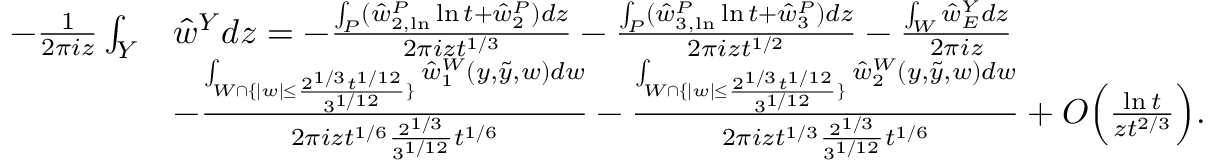Convert formula to latex. <formula><loc_0><loc_0><loc_500><loc_500>\begin{array} { r l } { - \frac { 1 } { 2 \pi i z } \int _ { Y } } & { \hat { w } ^ { Y } d z = - \frac { \int _ { P } ( \hat { w } _ { 2 , \ln } ^ { P } \ln { t } + \hat { w } _ { 2 } ^ { P } ) d z } { 2 \pi i z t ^ { 1 / 3 } } - \frac { \int _ { P } ( \hat { w } _ { 3 , \ln } ^ { P } \ln { t } + \hat { w } _ { 3 } ^ { P } ) d z } { 2 \pi i z t ^ { 1 / 2 } } - \frac { \int _ { W } \hat { w } _ { E } ^ { Y } d z } { 2 \pi i z } } \\ & { - \frac { \int _ { W \cap \{ | w | \leq \frac { 2 ^ { 1 / 3 } t ^ { 1 / 1 2 } } { 3 ^ { 1 / 1 2 } } \} } \hat { w } _ { 1 } ^ { W } ( y , \tilde { y } , w ) d w } { 2 \pi i z t ^ { 1 / 6 } \frac { 2 ^ { 1 / 3 } } { 3 ^ { 1 / 1 2 } } t ^ { 1 / 6 } } - \frac { \int _ { W \cap \{ | w | \leq \frac { 2 ^ { 1 / 3 } t ^ { 1 / 1 2 } } { 3 ^ { 1 / 1 2 } } \} } \hat { w } _ { 2 } ^ { W } ( y , \tilde { y } , w ) d w } { 2 \pi i z t ^ { 1 / 3 } \frac { 2 ^ { 1 / 3 } } { 3 ^ { 1 / 1 2 } } t ^ { 1 / 6 } } + O \left ( \frac { \ln { t } } { z t ^ { 2 / 3 } } \right ) . } \end{array}</formula> 